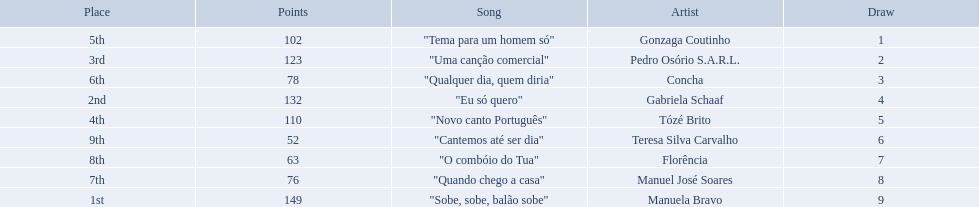What song place second in the contest? "Eu só quero". Who sang eu so quero? Gabriela Schaaf. Which artists sang in the eurovision song contest of 1979? Gonzaga Coutinho, Pedro Osório S.A.R.L., Concha, Gabriela Schaaf, Tózé Brito, Teresa Silva Carvalho, Florência, Manuel José Soares, Manuela Bravo. Of these, who sang eu so quero? Gabriela Schaaf. 